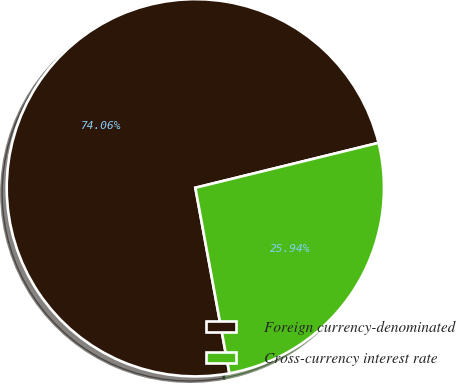Convert chart to OTSL. <chart><loc_0><loc_0><loc_500><loc_500><pie_chart><fcel>Foreign currency-denominated<fcel>Cross-currency interest rate<nl><fcel>74.06%<fcel>25.94%<nl></chart> 